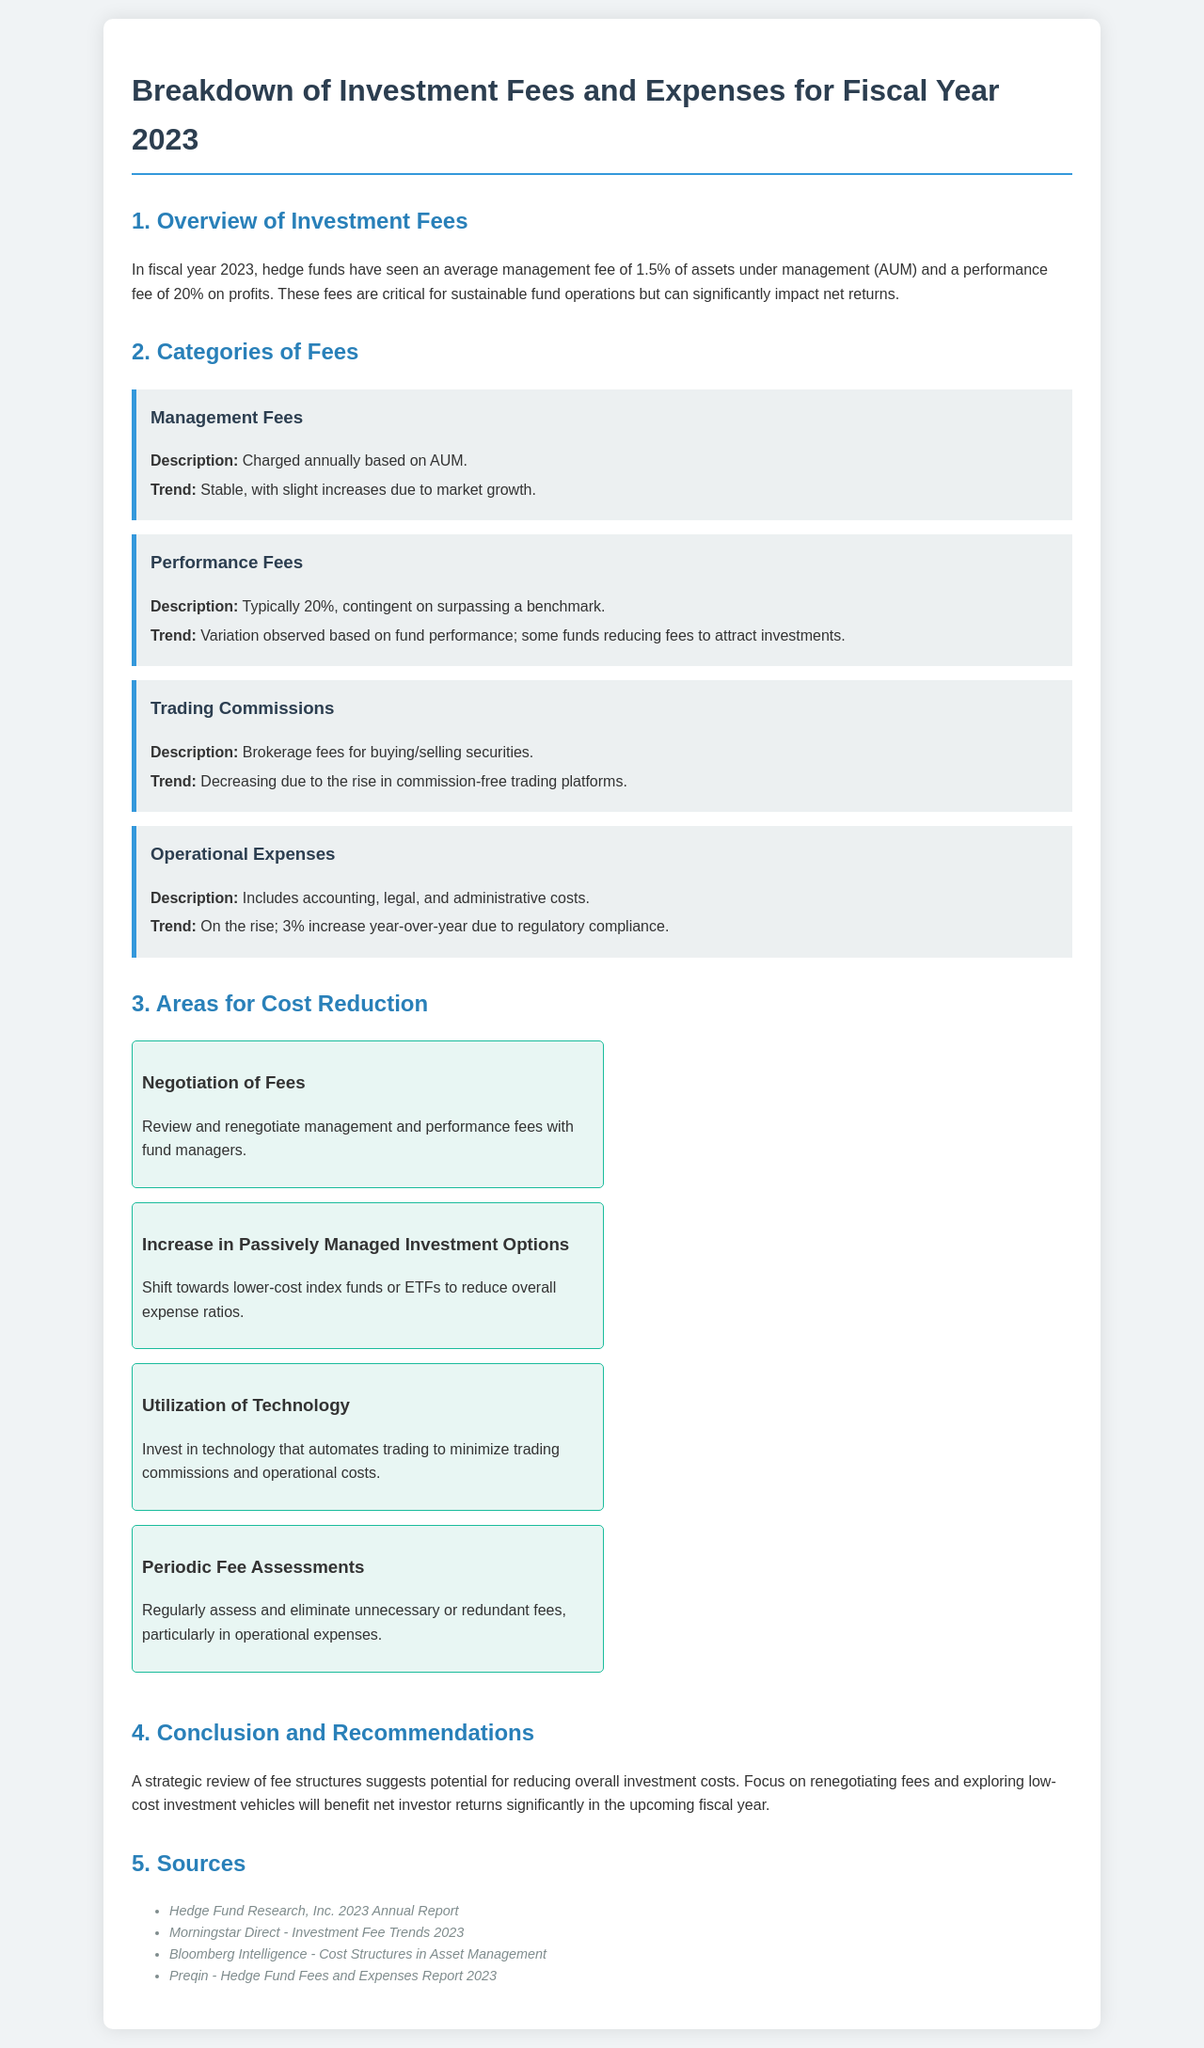What is the average management fee in fiscal year 2023? The average management fee for hedge funds in fiscal year 2023 is mentioned in the document.
Answer: 1.5% What percentage is typically charged for performance fees? The document specifies the typical performance fee percentage charged by hedge funds.
Answer: 20% What trend is observed in trading commissions? The trend in trading commissions is discussed in the document, highlighting the market's direction.
Answer: Decreasing What has caused operational expenses to rise? The document reveals the reason behind the increase in operational expenses.
Answer: Regulatory compliance Name one area identified for cost reduction. The document lists specific areas where cost reductions can occur, and one area is required here.
Answer: Negotiation of Fees What is mentioned as a method to reduce overall expense ratios? The document discusses strategies to lower expenses, including various investment options.
Answer: Passively Managed Investment Options How much have operational expenses increased year-over-year? This information can be found in the document, providing specific year-over-year growth details.
Answer: 3% What benefit is suggested for negotiation of fees? The document provides insights into the advantages gained from renegotiating fees.
Answer: Reduce overall investment costs What is the document's primary recommendation focus on? The main recommendation in the document is centered around improving specific financial aspects.
Answer: Renegotiating fees 